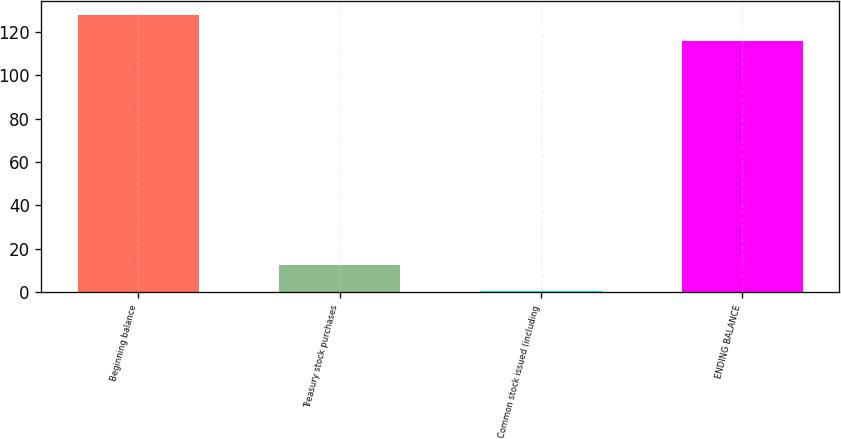Convert chart to OTSL. <chart><loc_0><loc_0><loc_500><loc_500><bar_chart><fcel>Beginning balance<fcel>Treasury stock purchases<fcel>Common stock issued (including<fcel>ENDING BALANCE<nl><fcel>127.72<fcel>12.82<fcel>0.8<fcel>115.7<nl></chart> 